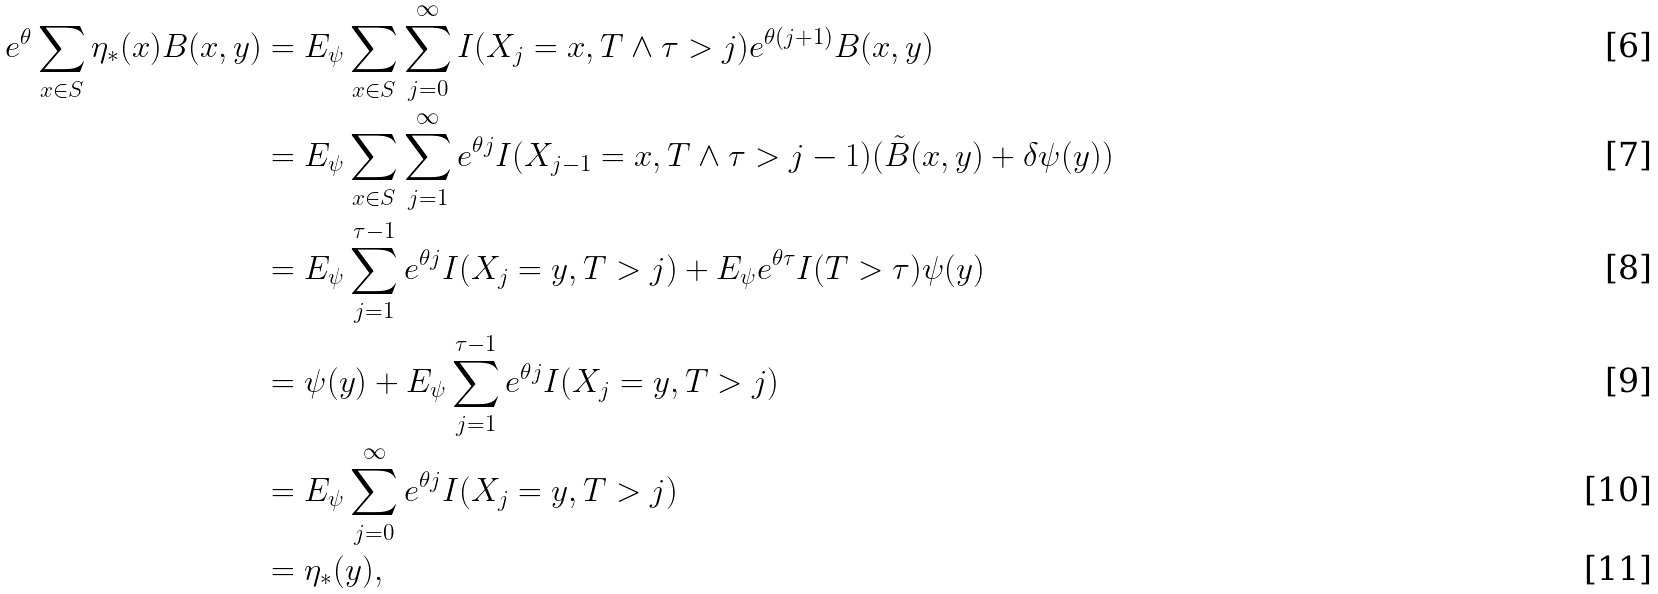Convert formula to latex. <formula><loc_0><loc_0><loc_500><loc_500>e ^ { \theta } \sum _ { x \in S } \eta _ { * } ( x ) B ( x , y ) & = E _ { \psi } \sum _ { x \in S } \sum _ { j = 0 } ^ { \infty } I ( X _ { j } = x , T \wedge \tau > j ) e ^ { \theta ( j + 1 ) } B ( x , y ) \\ & = E _ { \psi } \sum _ { x \in S } \sum _ { j = 1 } ^ { \infty } e ^ { \theta j } I ( X _ { j - 1 } = x , T \wedge \tau > j - 1 ) ( \tilde { B } ( x , y ) + \delta \psi ( y ) ) \\ & = E _ { \psi } \sum _ { j = 1 } ^ { \tau - 1 } e ^ { \theta j } I ( X _ { j } = y , T > j ) + E _ { \psi } e ^ { \theta \tau } I ( T > \tau ) \psi ( y ) \\ & = \psi ( y ) + E _ { \psi } \sum _ { j = 1 } ^ { \tau - 1 } e ^ { \theta j } I ( X _ { j } = y , T > j ) \\ & = E _ { \psi } \sum _ { j = 0 } ^ { \infty } e ^ { \theta j } I ( X _ { j } = y , T > j ) \\ & = \eta _ { * } ( y ) ,</formula> 